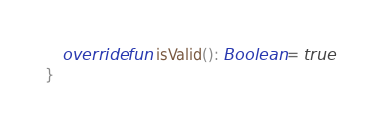<code> <loc_0><loc_0><loc_500><loc_500><_Kotlin_>    override fun isValid(): Boolean = true
}
</code> 